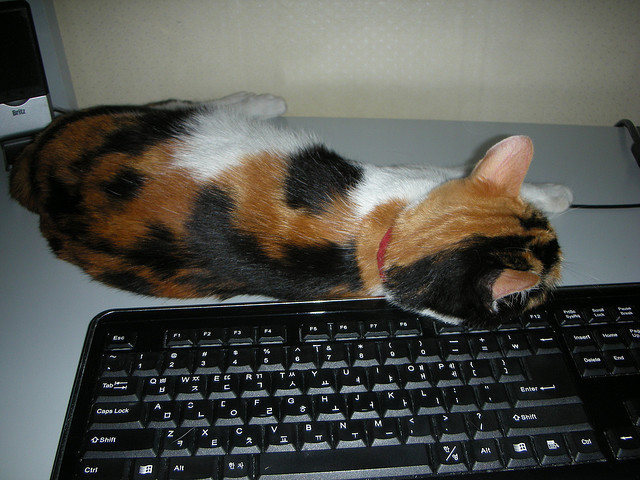Identify and read out the text in this image. Lock Shift A Insert End Delete Cape Ctrl Alt Ctrl Alt Shift Enter 0 U 9 7 0 4 2 J P O I U Y T R E W Q L K J H G F C S M N B V C X Z 